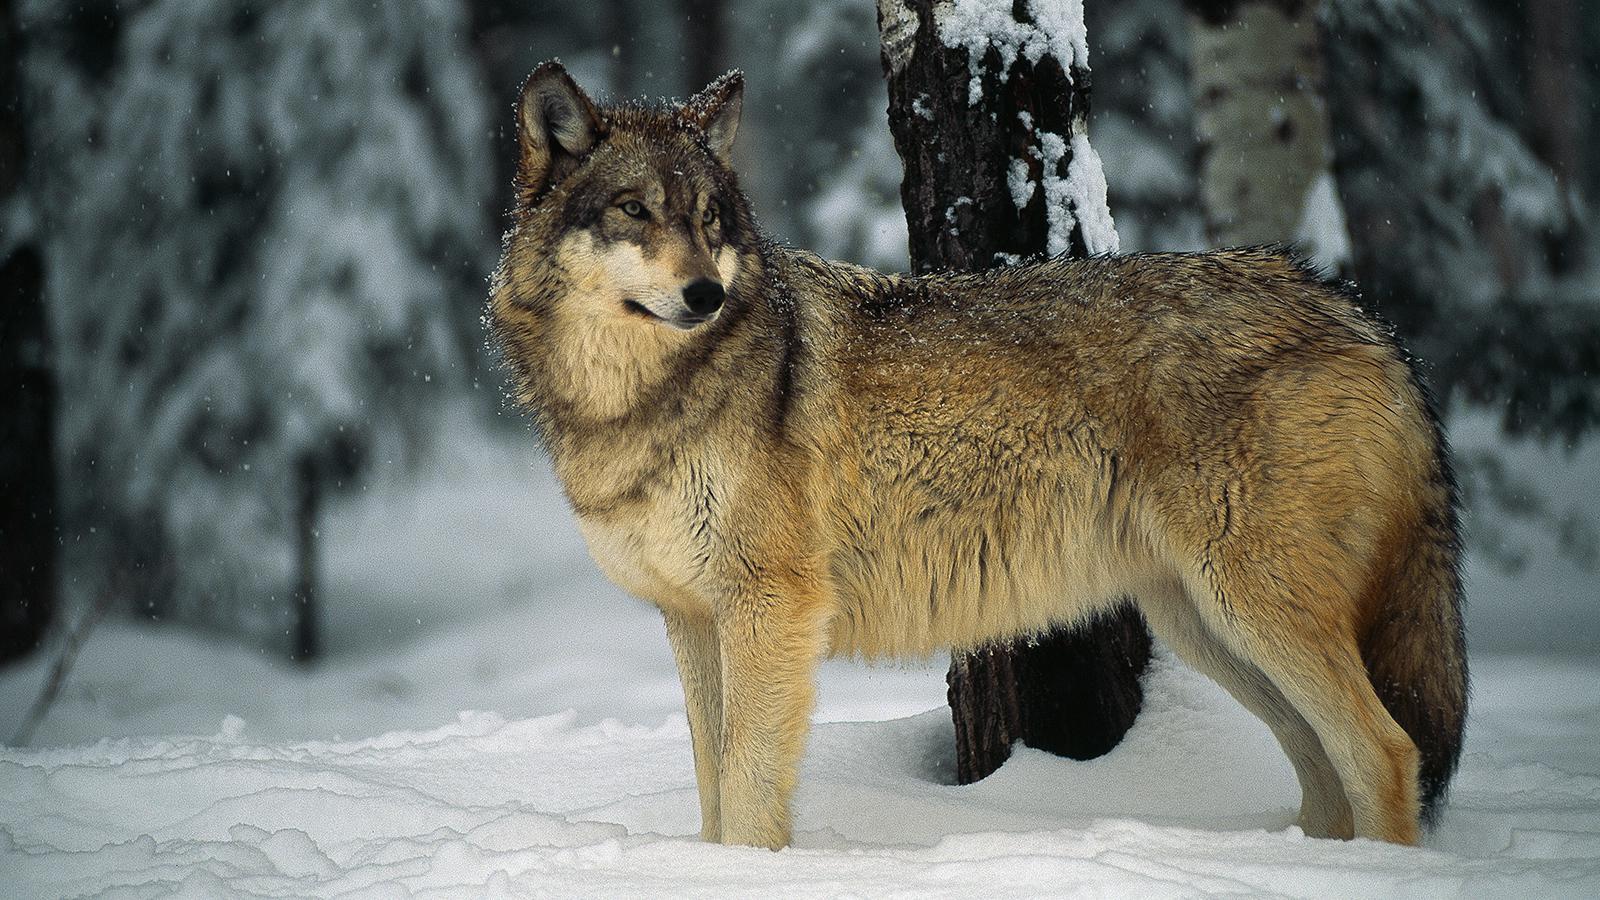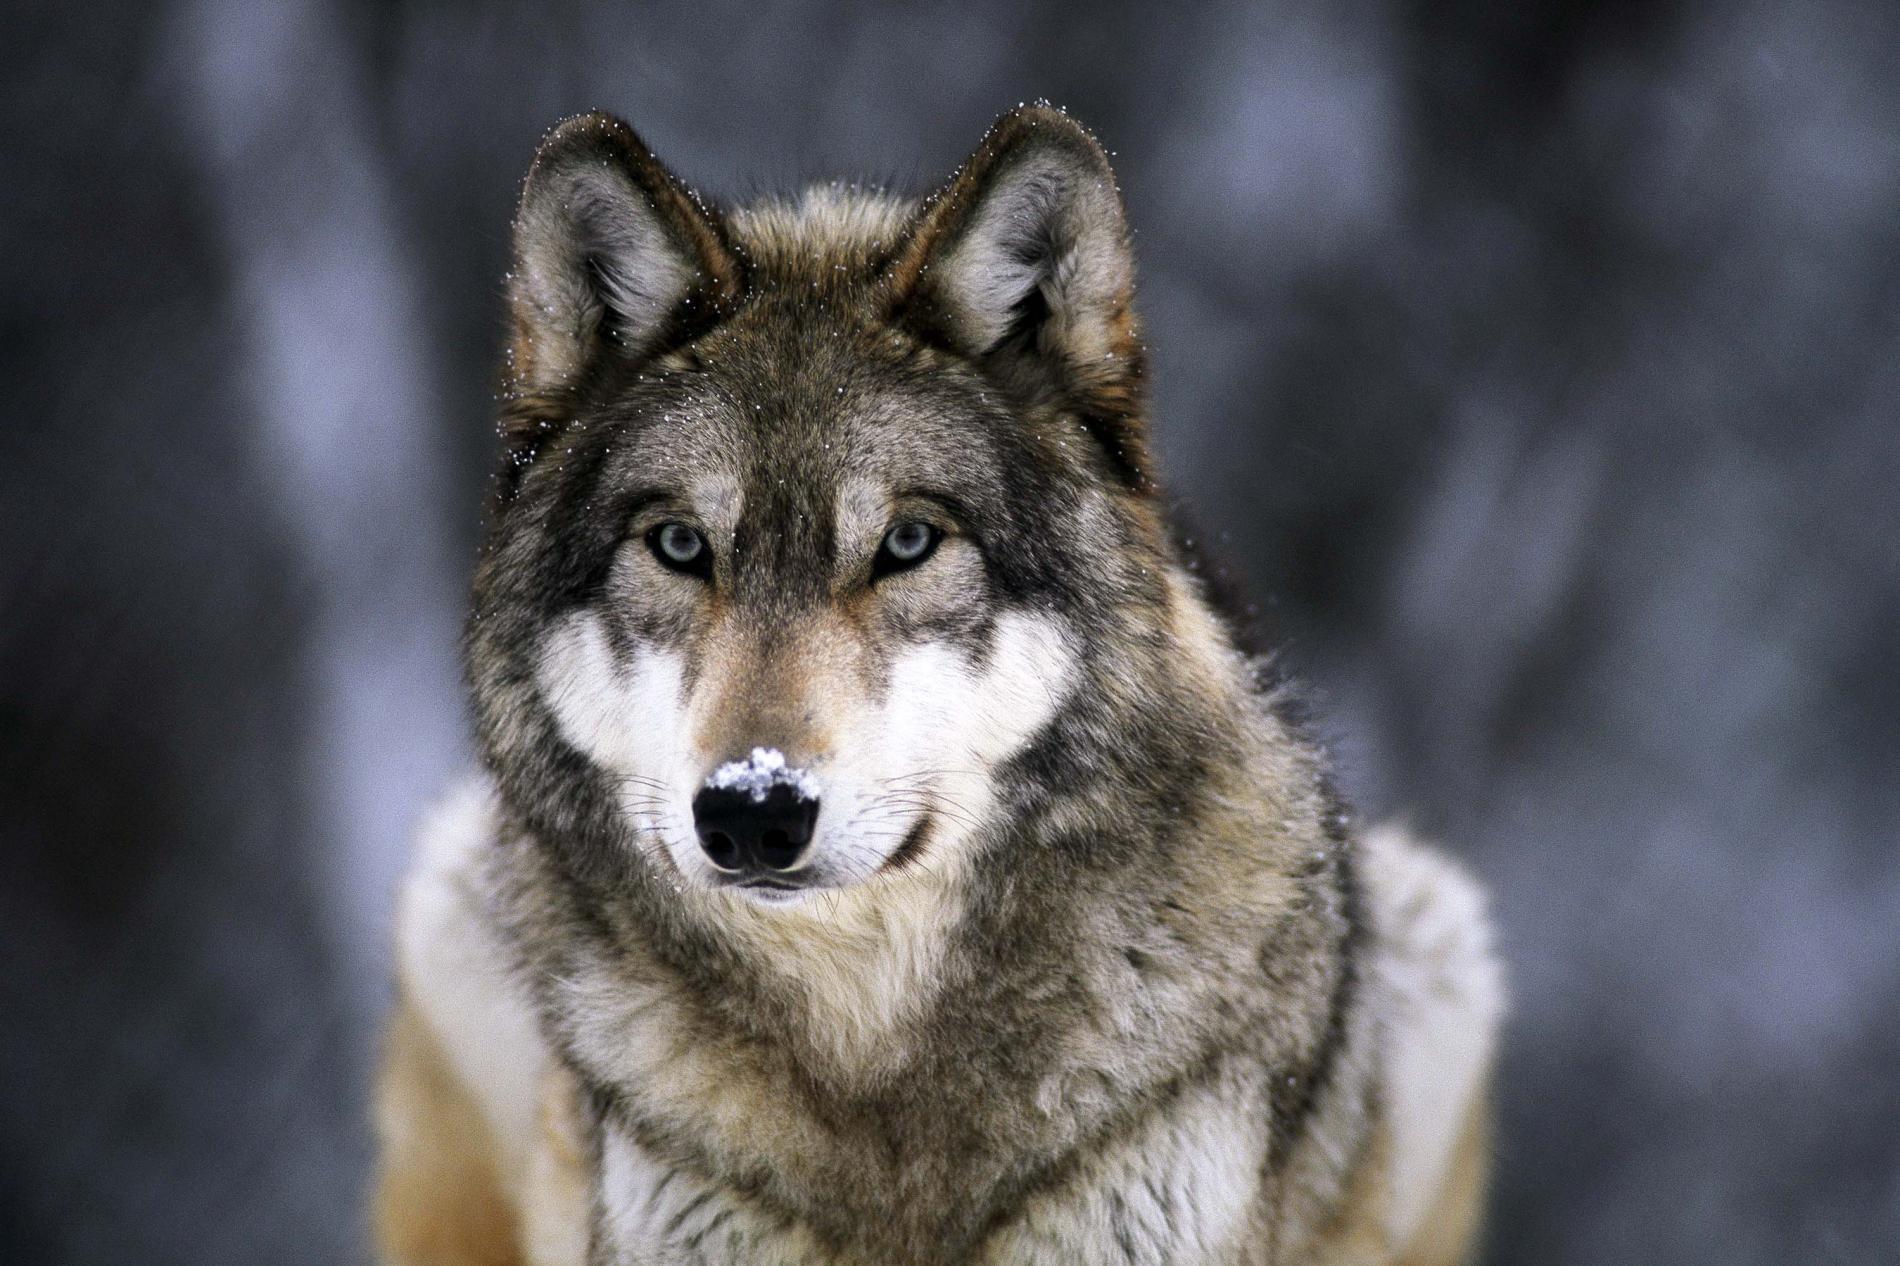The first image is the image on the left, the second image is the image on the right. For the images shown, is this caption "The animal in the image on the right has a white coat." true? Answer yes or no. No. 